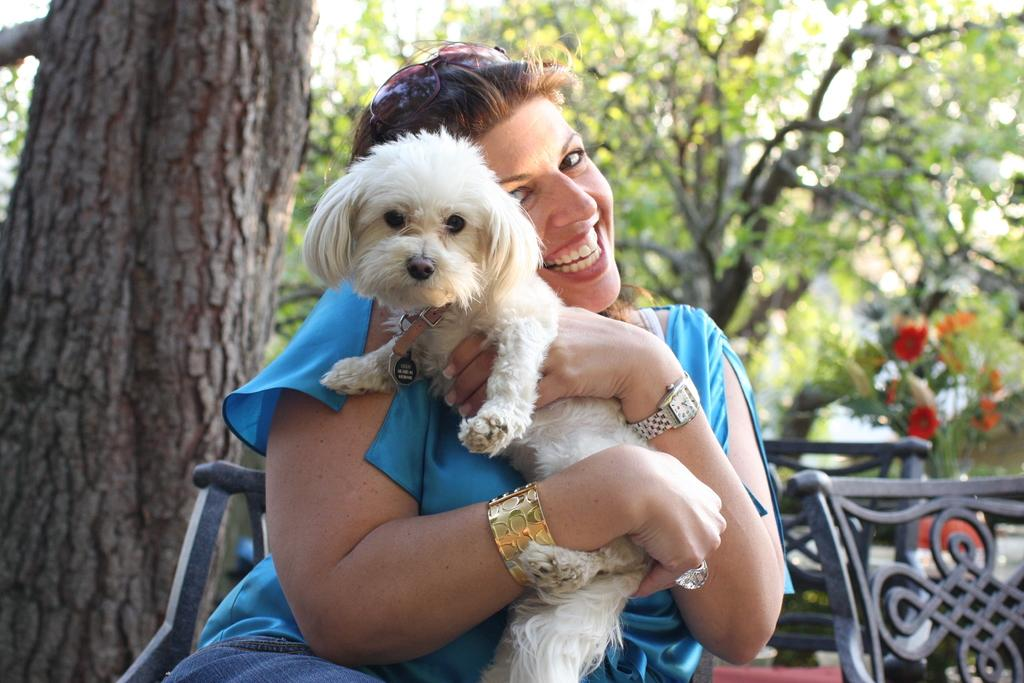Who is the main subject in the image? There is a lady in the center of the image. What is the lady doing in the image? The lady is sitting on a chair and holding a puppy. What can be seen in the background of the image? There are chairs, trees, and a flower pot in the background. What type of harbor can be seen in the image? There is no harbor present in the image. How does the lady manage to drive the puppy in the image? The lady is not driving the puppy in the image; she is simply holding it. 